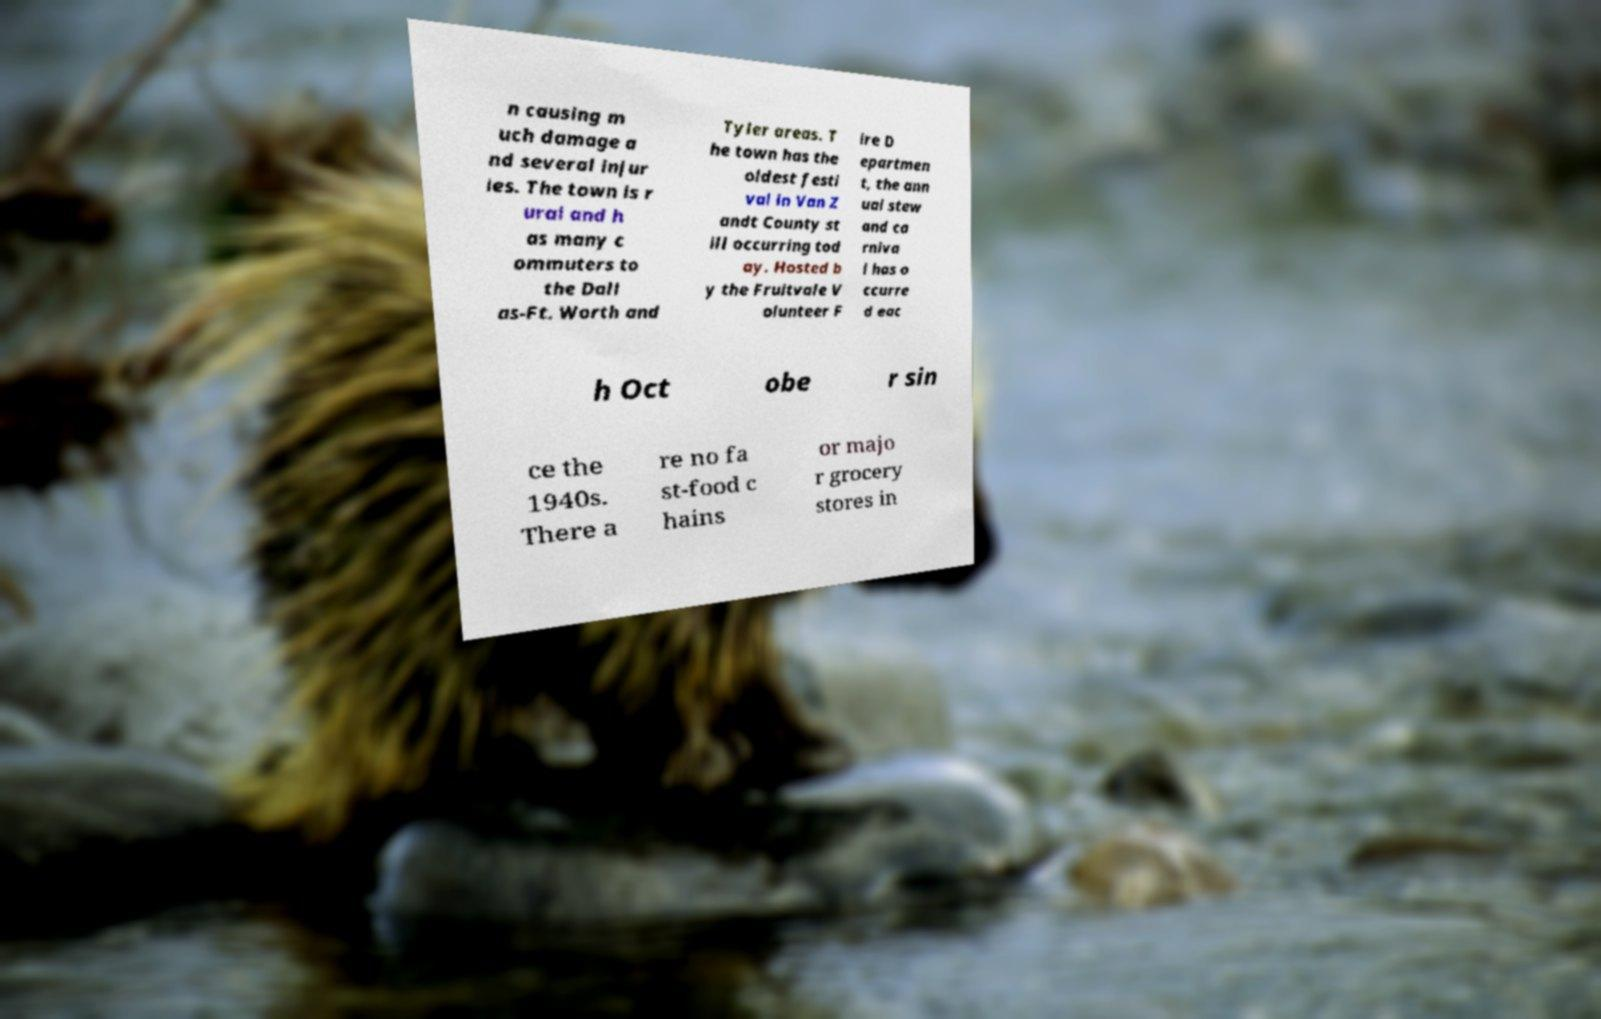I need the written content from this picture converted into text. Can you do that? n causing m uch damage a nd several injur ies. The town is r ural and h as many c ommuters to the Dall as-Ft. Worth and Tyler areas. T he town has the oldest festi val in Van Z andt County st ill occurring tod ay. Hosted b y the Fruitvale V olunteer F ire D epartmen t, the ann ual stew and ca rniva l has o ccurre d eac h Oct obe r sin ce the 1940s. There a re no fa st-food c hains or majo r grocery stores in 